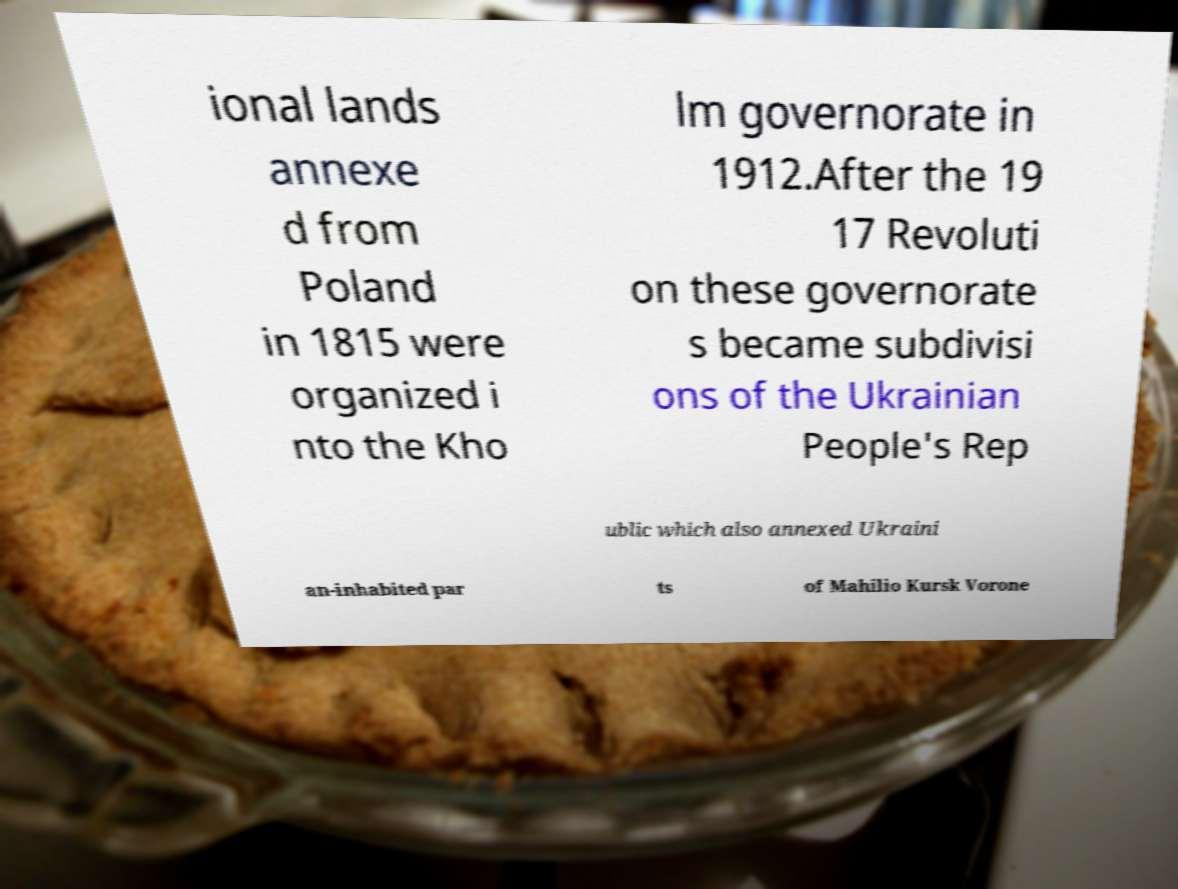Please identify and transcribe the text found in this image. ional lands annexe d from Poland in 1815 were organized i nto the Kho lm governorate in 1912.After the 19 17 Revoluti on these governorate s became subdivisi ons of the Ukrainian People's Rep ublic which also annexed Ukraini an-inhabited par ts of Mahilio Kursk Vorone 